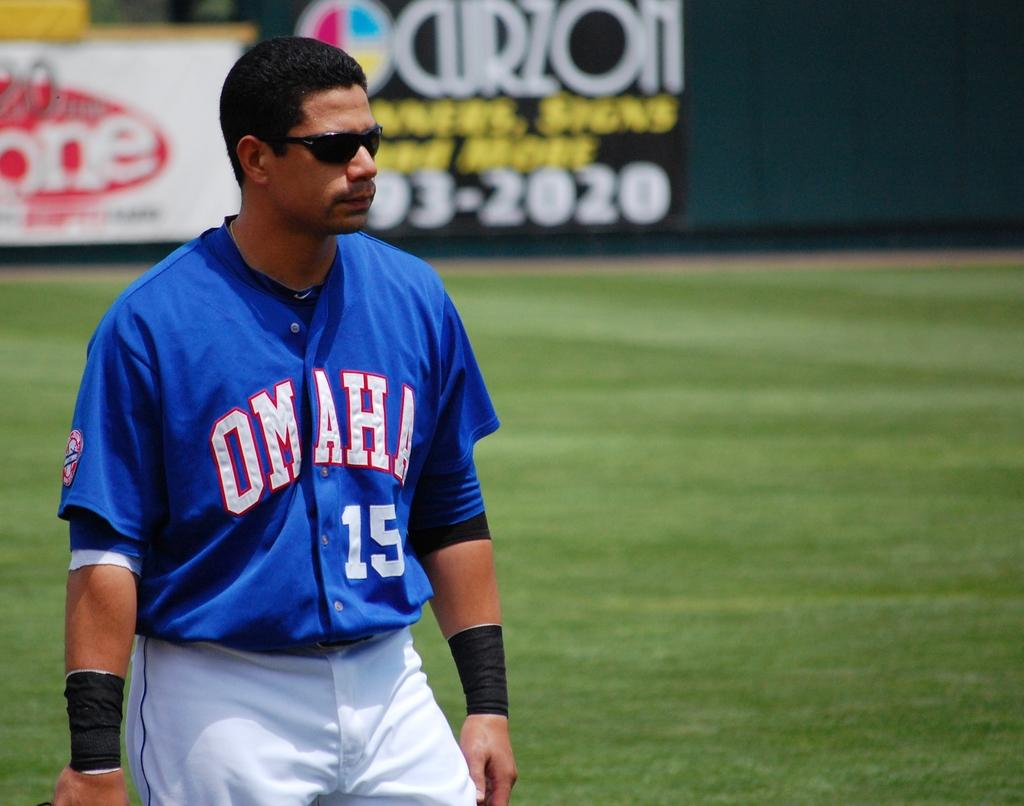<image>
Relay a brief, clear account of the picture shown. Baseball Player wearing an Omaha # 15 Jersey. 